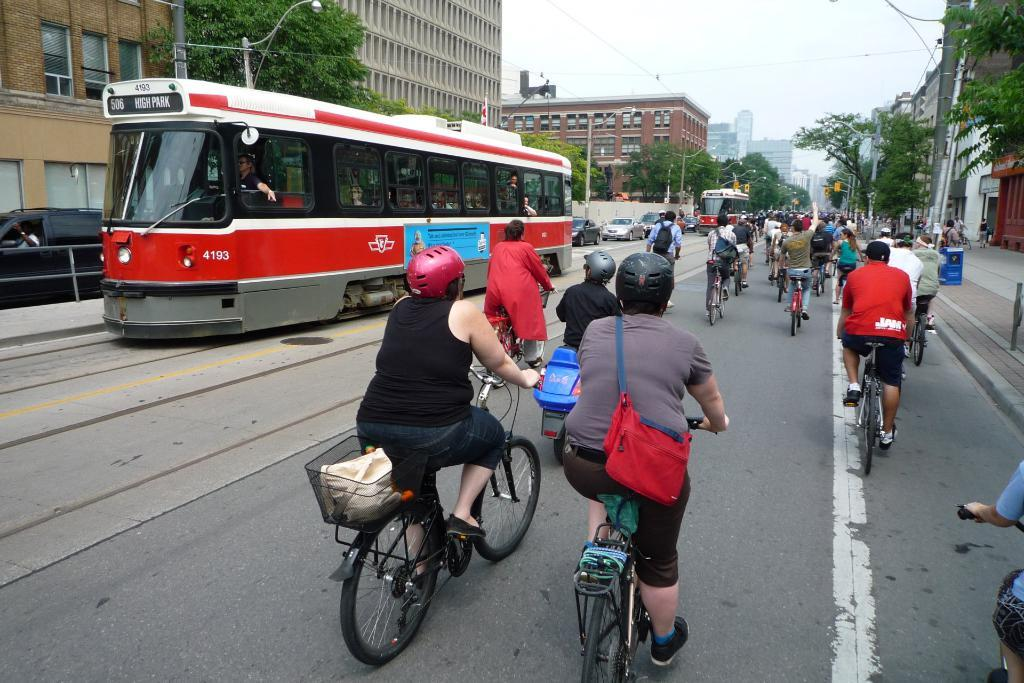What type of structures can be seen in the image? There are buildings in the image. What other natural elements are present in the image? There are trees in the image. What mode of transportation can be seen on the roads? Vehicles are present on the roads. What activity are some people engaged in? There are people riding bicycles. What safety precaution are the bicycle riders taking? The people riding bicycles are wearing helmets. Can you describe the belongings of one of the bicycle riders? One person is wearing a bag while riding a bicycle. What type of letters can be seen on the skin of the people in the image? There are no letters visible on the skin of the people in the image. What type of cord is used to connect the bicycles to the buildings? There is no cord connecting the bicycles to the buildings in the image. 